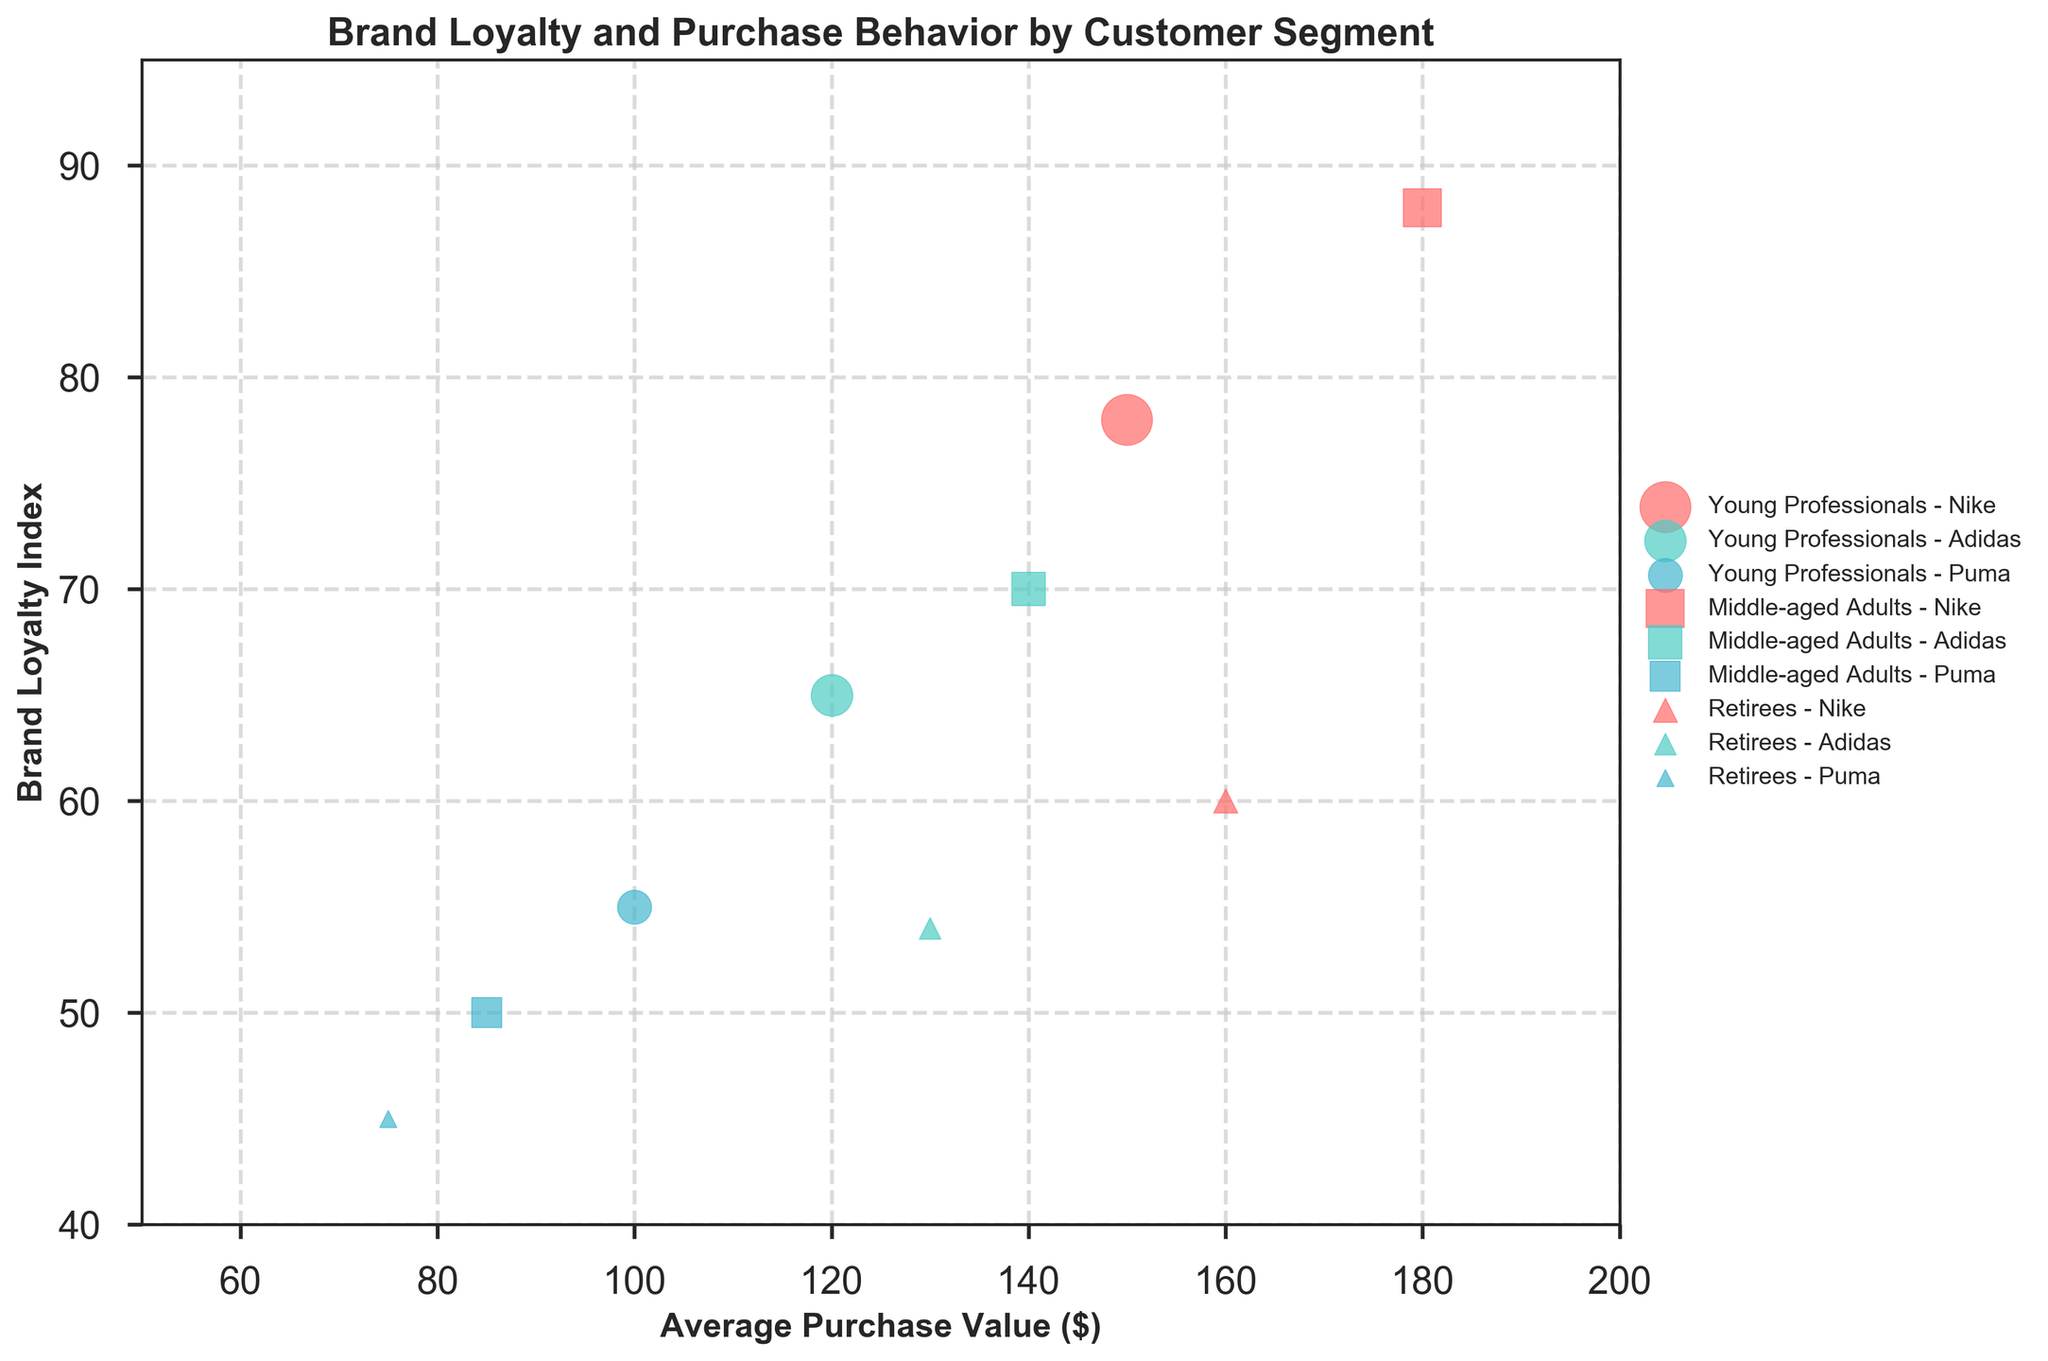What is the title of the figure? The title is displayed at the top of the figure.
Answer: Brand Loyalty and Purchase Behavior by Customer Segment What is the label of the x-axis? The label of the x-axis is shown below the horizontal line of the plot.
Answer: Average Purchase Value ($) Which customer segment has the highest Brand Loyalty Index for Nike? By looking at the vertical position of the Nike data points for each segment, the highest one shows the highest Brand Loyalty Index.
Answer: Middle-aged Adults How many distinct data points are there for each customer segment? Each segment has three data points corresponding to the three brands.
Answer: 3 What is the average Brand Loyalty Index of Adidas across all customer segments? Add the Brand Loyalty Index values of Adidas for each segment and then divide by the number of segments. (65 + 70 + 54) / 3 = 63
Answer: 63 Which data point represents the highest number of purchases? The size of the bubble indicates the number of purchases; the largest bubble has the highest number of purchases.
Answer: Young Professionals - Nike Compare the average purchase value for Adidas and Puma within the Middle-aged Adults segment. Which is higher? Compare the average purchase values for Adidas and Puma within the Middle-aged Adults segment. Adidas is 140, Puma is 85.
Answer: Adidas What is the range of the Brand Loyalty Index for Young Professionals? Find the highest and lowest values of the Brand Loyalty Index for Young Professionals (78 and 55 respectively) and subtract the lowest from the highest. 78 - 55 = 23
Answer: 23 Identify the customer segment and brand combination with the lowest Brand Loyalty Index. By looking for the lowest vertical position of all data points, the combination with the lowest index is found.
Answer: Retirees - Puma Which brand has the lowest average purchase value across all customer segments? Find the average purchase values for each brand segment by segment and compare them. Puma has 75, 85, and 100.
Answer: Puma 